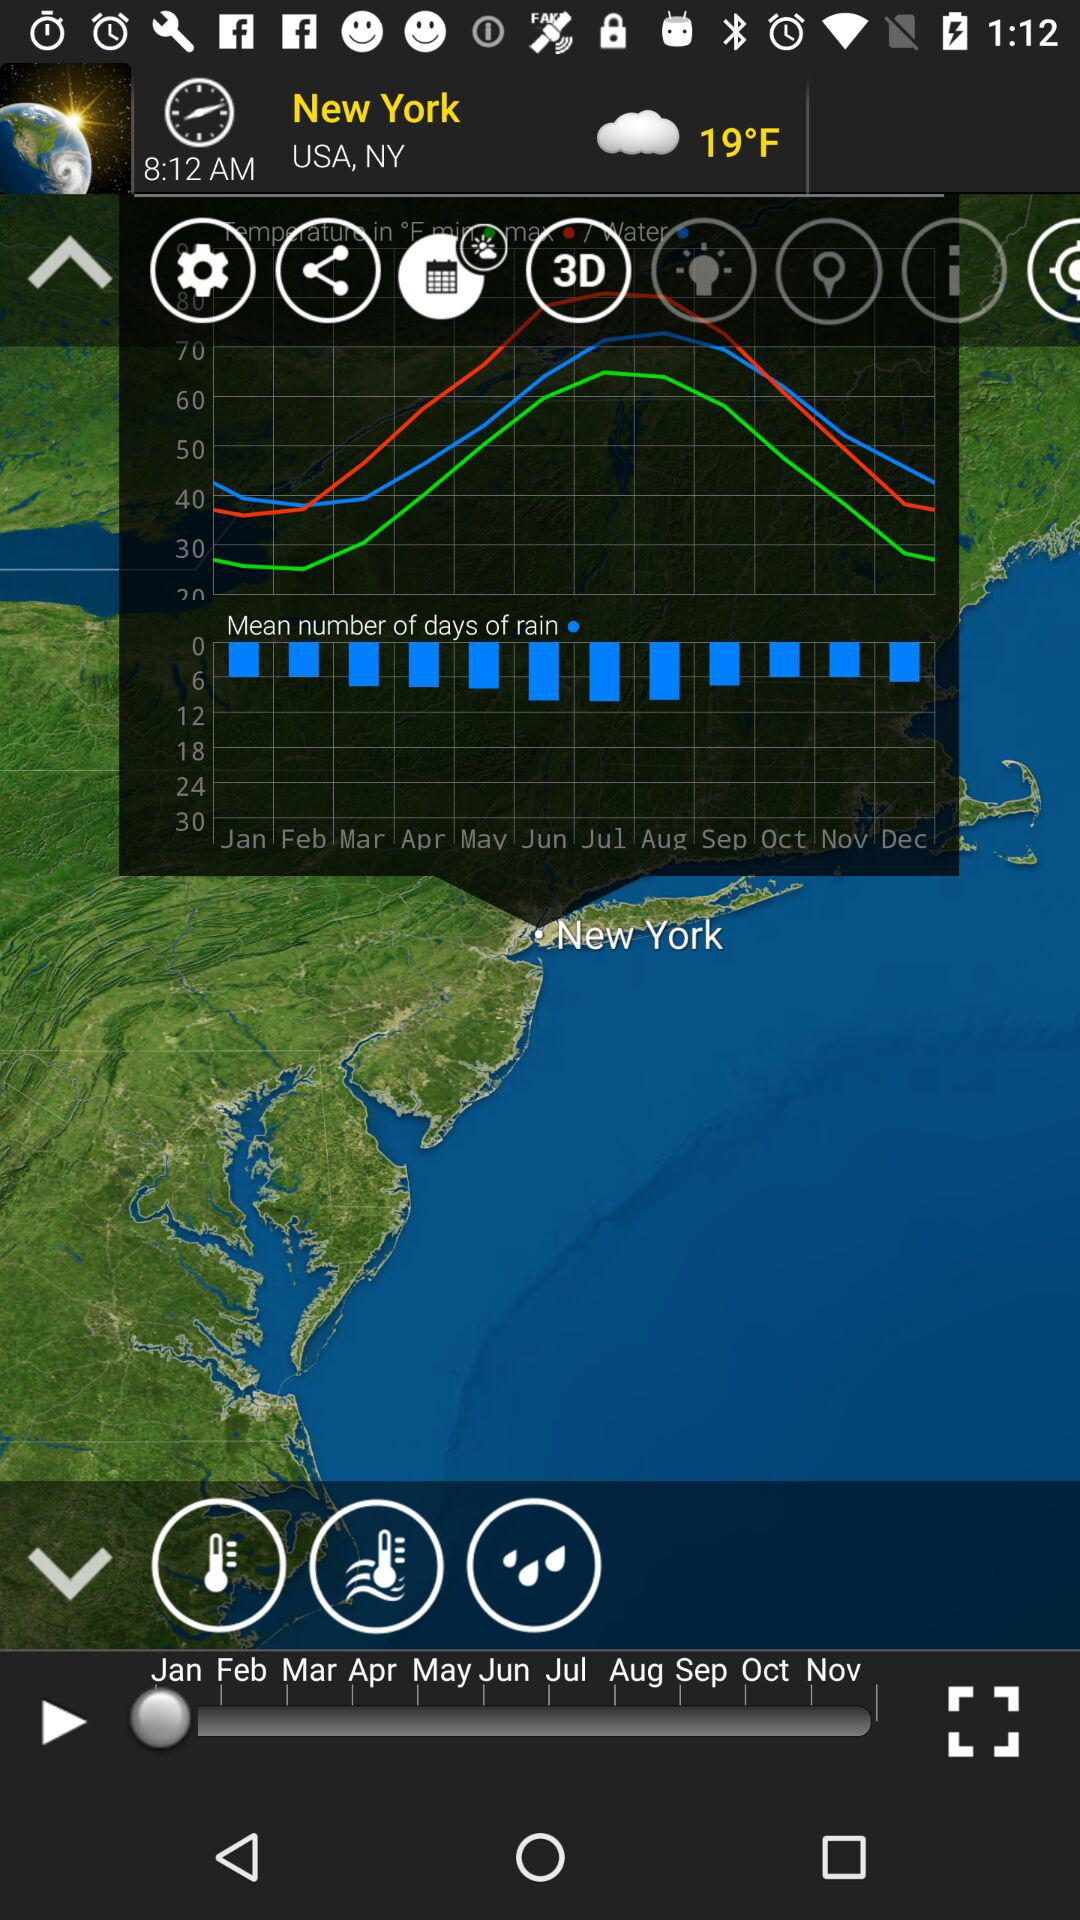What is the time? The time is 08:00 AM. 